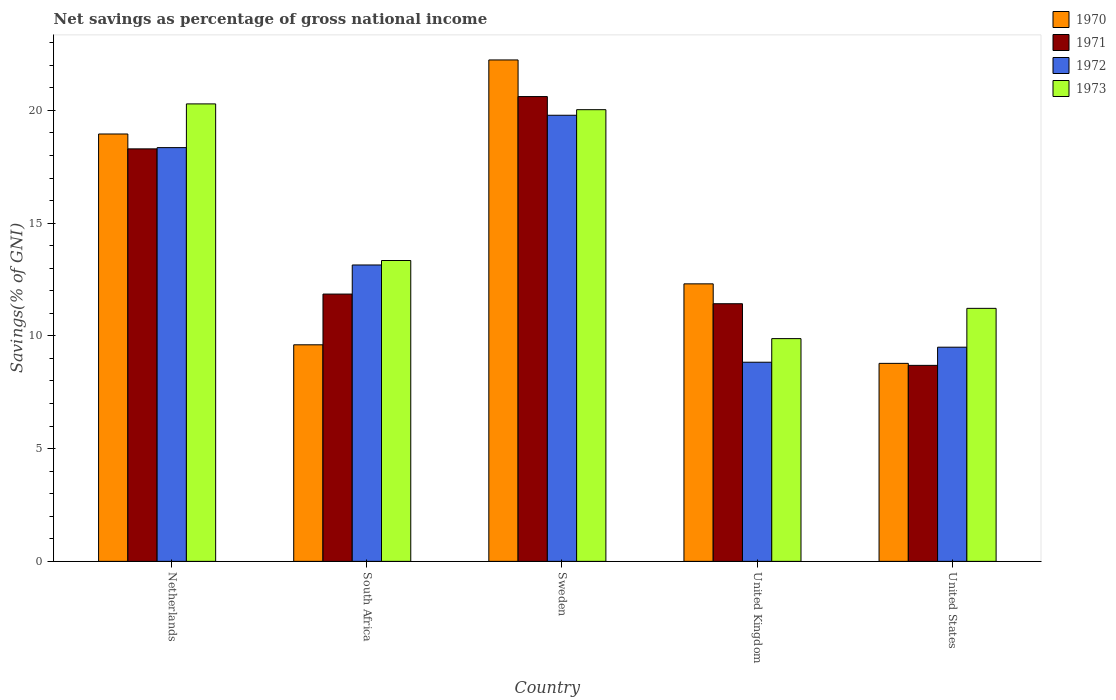Are the number of bars per tick equal to the number of legend labels?
Your response must be concise. Yes. Are the number of bars on each tick of the X-axis equal?
Make the answer very short. Yes. How many bars are there on the 4th tick from the left?
Keep it short and to the point. 4. In how many cases, is the number of bars for a given country not equal to the number of legend labels?
Your response must be concise. 0. What is the total savings in 1973 in South Africa?
Ensure brevity in your answer.  13.34. Across all countries, what is the maximum total savings in 1971?
Your answer should be compact. 20.61. Across all countries, what is the minimum total savings in 1973?
Give a very brief answer. 9.88. What is the total total savings in 1972 in the graph?
Your answer should be very brief. 69.6. What is the difference between the total savings in 1973 in Netherlands and that in United States?
Offer a terse response. 9.07. What is the difference between the total savings in 1972 in United Kingdom and the total savings in 1970 in Netherlands?
Give a very brief answer. -10.12. What is the average total savings in 1973 per country?
Offer a very short reply. 14.95. What is the difference between the total savings of/in 1972 and total savings of/in 1971 in United Kingdom?
Make the answer very short. -2.59. What is the ratio of the total savings in 1970 in South Africa to that in Sweden?
Make the answer very short. 0.43. What is the difference between the highest and the second highest total savings in 1973?
Your answer should be very brief. -6.95. What is the difference between the highest and the lowest total savings in 1972?
Make the answer very short. 10.95. In how many countries, is the total savings in 1970 greater than the average total savings in 1970 taken over all countries?
Provide a short and direct response. 2. Is the sum of the total savings in 1973 in Netherlands and United States greater than the maximum total savings in 1972 across all countries?
Keep it short and to the point. Yes. Is it the case that in every country, the sum of the total savings in 1972 and total savings in 1971 is greater than the sum of total savings in 1973 and total savings in 1970?
Offer a terse response. No. What does the 4th bar from the left in South Africa represents?
Make the answer very short. 1973. How many bars are there?
Give a very brief answer. 20. How many countries are there in the graph?
Ensure brevity in your answer.  5. What is the difference between two consecutive major ticks on the Y-axis?
Offer a terse response. 5. Are the values on the major ticks of Y-axis written in scientific E-notation?
Ensure brevity in your answer.  No. Where does the legend appear in the graph?
Make the answer very short. Top right. How many legend labels are there?
Offer a terse response. 4. How are the legend labels stacked?
Keep it short and to the point. Vertical. What is the title of the graph?
Make the answer very short. Net savings as percentage of gross national income. What is the label or title of the X-axis?
Provide a succinct answer. Country. What is the label or title of the Y-axis?
Offer a terse response. Savings(% of GNI). What is the Savings(% of GNI) in 1970 in Netherlands?
Keep it short and to the point. 18.95. What is the Savings(% of GNI) of 1971 in Netherlands?
Your answer should be very brief. 18.29. What is the Savings(% of GNI) of 1972 in Netherlands?
Give a very brief answer. 18.35. What is the Savings(% of GNI) in 1973 in Netherlands?
Your answer should be compact. 20.29. What is the Savings(% of GNI) of 1970 in South Africa?
Your answer should be very brief. 9.6. What is the Savings(% of GNI) in 1971 in South Africa?
Offer a terse response. 11.85. What is the Savings(% of GNI) of 1972 in South Africa?
Offer a very short reply. 13.14. What is the Savings(% of GNI) of 1973 in South Africa?
Ensure brevity in your answer.  13.34. What is the Savings(% of GNI) in 1970 in Sweden?
Keep it short and to the point. 22.24. What is the Savings(% of GNI) in 1971 in Sweden?
Offer a very short reply. 20.61. What is the Savings(% of GNI) of 1972 in Sweden?
Offer a very short reply. 19.78. What is the Savings(% of GNI) in 1973 in Sweden?
Your response must be concise. 20.03. What is the Savings(% of GNI) of 1970 in United Kingdom?
Your answer should be compact. 12.31. What is the Savings(% of GNI) of 1971 in United Kingdom?
Provide a short and direct response. 11.43. What is the Savings(% of GNI) of 1972 in United Kingdom?
Your answer should be compact. 8.83. What is the Savings(% of GNI) in 1973 in United Kingdom?
Your response must be concise. 9.88. What is the Savings(% of GNI) in 1970 in United States?
Give a very brief answer. 8.78. What is the Savings(% of GNI) of 1971 in United States?
Provide a short and direct response. 8.69. What is the Savings(% of GNI) in 1972 in United States?
Offer a very short reply. 9.5. What is the Savings(% of GNI) of 1973 in United States?
Your answer should be very brief. 11.22. Across all countries, what is the maximum Savings(% of GNI) of 1970?
Ensure brevity in your answer.  22.24. Across all countries, what is the maximum Savings(% of GNI) in 1971?
Ensure brevity in your answer.  20.61. Across all countries, what is the maximum Savings(% of GNI) of 1972?
Make the answer very short. 19.78. Across all countries, what is the maximum Savings(% of GNI) in 1973?
Your response must be concise. 20.29. Across all countries, what is the minimum Savings(% of GNI) in 1970?
Your response must be concise. 8.78. Across all countries, what is the minimum Savings(% of GNI) in 1971?
Keep it short and to the point. 8.69. Across all countries, what is the minimum Savings(% of GNI) of 1972?
Your answer should be compact. 8.83. Across all countries, what is the minimum Savings(% of GNI) of 1973?
Ensure brevity in your answer.  9.88. What is the total Savings(% of GNI) of 1970 in the graph?
Your response must be concise. 71.88. What is the total Savings(% of GNI) of 1971 in the graph?
Provide a short and direct response. 70.88. What is the total Savings(% of GNI) in 1972 in the graph?
Offer a terse response. 69.61. What is the total Savings(% of GNI) in 1973 in the graph?
Keep it short and to the point. 74.76. What is the difference between the Savings(% of GNI) of 1970 in Netherlands and that in South Africa?
Ensure brevity in your answer.  9.35. What is the difference between the Savings(% of GNI) in 1971 in Netherlands and that in South Africa?
Provide a succinct answer. 6.44. What is the difference between the Savings(% of GNI) in 1972 in Netherlands and that in South Africa?
Your answer should be compact. 5.21. What is the difference between the Savings(% of GNI) in 1973 in Netherlands and that in South Africa?
Provide a short and direct response. 6.95. What is the difference between the Savings(% of GNI) of 1970 in Netherlands and that in Sweden?
Give a very brief answer. -3.28. What is the difference between the Savings(% of GNI) of 1971 in Netherlands and that in Sweden?
Your answer should be very brief. -2.32. What is the difference between the Savings(% of GNI) of 1972 in Netherlands and that in Sweden?
Make the answer very short. -1.43. What is the difference between the Savings(% of GNI) of 1973 in Netherlands and that in Sweden?
Offer a terse response. 0.26. What is the difference between the Savings(% of GNI) in 1970 in Netherlands and that in United Kingdom?
Make the answer very short. 6.65. What is the difference between the Savings(% of GNI) of 1971 in Netherlands and that in United Kingdom?
Give a very brief answer. 6.87. What is the difference between the Savings(% of GNI) in 1972 in Netherlands and that in United Kingdom?
Provide a succinct answer. 9.52. What is the difference between the Savings(% of GNI) of 1973 in Netherlands and that in United Kingdom?
Provide a short and direct response. 10.41. What is the difference between the Savings(% of GNI) in 1970 in Netherlands and that in United States?
Your answer should be very brief. 10.17. What is the difference between the Savings(% of GNI) of 1971 in Netherlands and that in United States?
Your answer should be compact. 9.6. What is the difference between the Savings(% of GNI) in 1972 in Netherlands and that in United States?
Provide a succinct answer. 8.85. What is the difference between the Savings(% of GNI) in 1973 in Netherlands and that in United States?
Make the answer very short. 9.07. What is the difference between the Savings(% of GNI) in 1970 in South Africa and that in Sweden?
Keep it short and to the point. -12.63. What is the difference between the Savings(% of GNI) of 1971 in South Africa and that in Sweden?
Make the answer very short. -8.76. What is the difference between the Savings(% of GNI) of 1972 in South Africa and that in Sweden?
Offer a terse response. -6.64. What is the difference between the Savings(% of GNI) of 1973 in South Africa and that in Sweden?
Your answer should be compact. -6.69. What is the difference between the Savings(% of GNI) of 1970 in South Africa and that in United Kingdom?
Provide a succinct answer. -2.7. What is the difference between the Savings(% of GNI) in 1971 in South Africa and that in United Kingdom?
Provide a short and direct response. 0.43. What is the difference between the Savings(% of GNI) in 1972 in South Africa and that in United Kingdom?
Provide a short and direct response. 4.31. What is the difference between the Savings(% of GNI) of 1973 in South Africa and that in United Kingdom?
Keep it short and to the point. 3.46. What is the difference between the Savings(% of GNI) in 1970 in South Africa and that in United States?
Your answer should be compact. 0.82. What is the difference between the Savings(% of GNI) in 1971 in South Africa and that in United States?
Your response must be concise. 3.16. What is the difference between the Savings(% of GNI) in 1972 in South Africa and that in United States?
Offer a very short reply. 3.65. What is the difference between the Savings(% of GNI) in 1973 in South Africa and that in United States?
Your answer should be very brief. 2.12. What is the difference between the Savings(% of GNI) of 1970 in Sweden and that in United Kingdom?
Your response must be concise. 9.93. What is the difference between the Savings(% of GNI) in 1971 in Sweden and that in United Kingdom?
Give a very brief answer. 9.19. What is the difference between the Savings(% of GNI) in 1972 in Sweden and that in United Kingdom?
Provide a short and direct response. 10.95. What is the difference between the Savings(% of GNI) in 1973 in Sweden and that in United Kingdom?
Provide a short and direct response. 10.15. What is the difference between the Savings(% of GNI) in 1970 in Sweden and that in United States?
Provide a short and direct response. 13.46. What is the difference between the Savings(% of GNI) in 1971 in Sweden and that in United States?
Make the answer very short. 11.92. What is the difference between the Savings(% of GNI) in 1972 in Sweden and that in United States?
Your answer should be compact. 10.29. What is the difference between the Savings(% of GNI) in 1973 in Sweden and that in United States?
Make the answer very short. 8.81. What is the difference between the Savings(% of GNI) in 1970 in United Kingdom and that in United States?
Your answer should be very brief. 3.53. What is the difference between the Savings(% of GNI) of 1971 in United Kingdom and that in United States?
Offer a terse response. 2.73. What is the difference between the Savings(% of GNI) of 1972 in United Kingdom and that in United States?
Your answer should be very brief. -0.67. What is the difference between the Savings(% of GNI) of 1973 in United Kingdom and that in United States?
Ensure brevity in your answer.  -1.34. What is the difference between the Savings(% of GNI) of 1970 in Netherlands and the Savings(% of GNI) of 1971 in South Africa?
Offer a very short reply. 7.1. What is the difference between the Savings(% of GNI) of 1970 in Netherlands and the Savings(% of GNI) of 1972 in South Africa?
Give a very brief answer. 5.81. What is the difference between the Savings(% of GNI) of 1970 in Netherlands and the Savings(% of GNI) of 1973 in South Africa?
Ensure brevity in your answer.  5.61. What is the difference between the Savings(% of GNI) in 1971 in Netherlands and the Savings(% of GNI) in 1972 in South Africa?
Your answer should be very brief. 5.15. What is the difference between the Savings(% of GNI) in 1971 in Netherlands and the Savings(% of GNI) in 1973 in South Africa?
Ensure brevity in your answer.  4.95. What is the difference between the Savings(% of GNI) in 1972 in Netherlands and the Savings(% of GNI) in 1973 in South Africa?
Provide a short and direct response. 5.01. What is the difference between the Savings(% of GNI) in 1970 in Netherlands and the Savings(% of GNI) in 1971 in Sweden?
Make the answer very short. -1.66. What is the difference between the Savings(% of GNI) of 1970 in Netherlands and the Savings(% of GNI) of 1972 in Sweden?
Your answer should be very brief. -0.83. What is the difference between the Savings(% of GNI) of 1970 in Netherlands and the Savings(% of GNI) of 1973 in Sweden?
Your answer should be compact. -1.08. What is the difference between the Savings(% of GNI) of 1971 in Netherlands and the Savings(% of GNI) of 1972 in Sweden?
Offer a very short reply. -1.49. What is the difference between the Savings(% of GNI) of 1971 in Netherlands and the Savings(% of GNI) of 1973 in Sweden?
Your answer should be very brief. -1.74. What is the difference between the Savings(% of GNI) in 1972 in Netherlands and the Savings(% of GNI) in 1973 in Sweden?
Your answer should be very brief. -1.68. What is the difference between the Savings(% of GNI) in 1970 in Netherlands and the Savings(% of GNI) in 1971 in United Kingdom?
Give a very brief answer. 7.53. What is the difference between the Savings(% of GNI) of 1970 in Netherlands and the Savings(% of GNI) of 1972 in United Kingdom?
Give a very brief answer. 10.12. What is the difference between the Savings(% of GNI) in 1970 in Netherlands and the Savings(% of GNI) in 1973 in United Kingdom?
Your response must be concise. 9.07. What is the difference between the Savings(% of GNI) in 1971 in Netherlands and the Savings(% of GNI) in 1972 in United Kingdom?
Your answer should be very brief. 9.46. What is the difference between the Savings(% of GNI) in 1971 in Netherlands and the Savings(% of GNI) in 1973 in United Kingdom?
Your answer should be very brief. 8.42. What is the difference between the Savings(% of GNI) in 1972 in Netherlands and the Savings(% of GNI) in 1973 in United Kingdom?
Make the answer very short. 8.47. What is the difference between the Savings(% of GNI) in 1970 in Netherlands and the Savings(% of GNI) in 1971 in United States?
Your answer should be compact. 10.26. What is the difference between the Savings(% of GNI) of 1970 in Netherlands and the Savings(% of GNI) of 1972 in United States?
Give a very brief answer. 9.46. What is the difference between the Savings(% of GNI) in 1970 in Netherlands and the Savings(% of GNI) in 1973 in United States?
Your response must be concise. 7.73. What is the difference between the Savings(% of GNI) of 1971 in Netherlands and the Savings(% of GNI) of 1972 in United States?
Give a very brief answer. 8.8. What is the difference between the Savings(% of GNI) in 1971 in Netherlands and the Savings(% of GNI) in 1973 in United States?
Your response must be concise. 7.07. What is the difference between the Savings(% of GNI) of 1972 in Netherlands and the Savings(% of GNI) of 1973 in United States?
Offer a very short reply. 7.13. What is the difference between the Savings(% of GNI) in 1970 in South Africa and the Savings(% of GNI) in 1971 in Sweden?
Give a very brief answer. -11.01. What is the difference between the Savings(% of GNI) of 1970 in South Africa and the Savings(% of GNI) of 1972 in Sweden?
Your answer should be compact. -10.18. What is the difference between the Savings(% of GNI) of 1970 in South Africa and the Savings(% of GNI) of 1973 in Sweden?
Your answer should be very brief. -10.43. What is the difference between the Savings(% of GNI) of 1971 in South Africa and the Savings(% of GNI) of 1972 in Sweden?
Ensure brevity in your answer.  -7.93. What is the difference between the Savings(% of GNI) in 1971 in South Africa and the Savings(% of GNI) in 1973 in Sweden?
Provide a short and direct response. -8.18. What is the difference between the Savings(% of GNI) of 1972 in South Africa and the Savings(% of GNI) of 1973 in Sweden?
Ensure brevity in your answer.  -6.89. What is the difference between the Savings(% of GNI) in 1970 in South Africa and the Savings(% of GNI) in 1971 in United Kingdom?
Keep it short and to the point. -1.82. What is the difference between the Savings(% of GNI) in 1970 in South Africa and the Savings(% of GNI) in 1972 in United Kingdom?
Offer a very short reply. 0.77. What is the difference between the Savings(% of GNI) of 1970 in South Africa and the Savings(% of GNI) of 1973 in United Kingdom?
Provide a short and direct response. -0.27. What is the difference between the Savings(% of GNI) in 1971 in South Africa and the Savings(% of GNI) in 1972 in United Kingdom?
Offer a very short reply. 3.02. What is the difference between the Savings(% of GNI) in 1971 in South Africa and the Savings(% of GNI) in 1973 in United Kingdom?
Give a very brief answer. 1.98. What is the difference between the Savings(% of GNI) of 1972 in South Africa and the Savings(% of GNI) of 1973 in United Kingdom?
Give a very brief answer. 3.27. What is the difference between the Savings(% of GNI) of 1970 in South Africa and the Savings(% of GNI) of 1971 in United States?
Give a very brief answer. 0.91. What is the difference between the Savings(% of GNI) of 1970 in South Africa and the Savings(% of GNI) of 1972 in United States?
Keep it short and to the point. 0.11. What is the difference between the Savings(% of GNI) in 1970 in South Africa and the Savings(% of GNI) in 1973 in United States?
Your answer should be very brief. -1.62. What is the difference between the Savings(% of GNI) in 1971 in South Africa and the Savings(% of GNI) in 1972 in United States?
Ensure brevity in your answer.  2.36. What is the difference between the Savings(% of GNI) in 1971 in South Africa and the Savings(% of GNI) in 1973 in United States?
Offer a terse response. 0.63. What is the difference between the Savings(% of GNI) of 1972 in South Africa and the Savings(% of GNI) of 1973 in United States?
Your answer should be very brief. 1.92. What is the difference between the Savings(% of GNI) of 1970 in Sweden and the Savings(% of GNI) of 1971 in United Kingdom?
Give a very brief answer. 10.81. What is the difference between the Savings(% of GNI) in 1970 in Sweden and the Savings(% of GNI) in 1972 in United Kingdom?
Your response must be concise. 13.41. What is the difference between the Savings(% of GNI) in 1970 in Sweden and the Savings(% of GNI) in 1973 in United Kingdom?
Keep it short and to the point. 12.36. What is the difference between the Savings(% of GNI) in 1971 in Sweden and the Savings(% of GNI) in 1972 in United Kingdom?
Make the answer very short. 11.78. What is the difference between the Savings(% of GNI) of 1971 in Sweden and the Savings(% of GNI) of 1973 in United Kingdom?
Ensure brevity in your answer.  10.73. What is the difference between the Savings(% of GNI) of 1972 in Sweden and the Savings(% of GNI) of 1973 in United Kingdom?
Your answer should be very brief. 9.91. What is the difference between the Savings(% of GNI) of 1970 in Sweden and the Savings(% of GNI) of 1971 in United States?
Offer a very short reply. 13.54. What is the difference between the Savings(% of GNI) in 1970 in Sweden and the Savings(% of GNI) in 1972 in United States?
Make the answer very short. 12.74. What is the difference between the Savings(% of GNI) of 1970 in Sweden and the Savings(% of GNI) of 1973 in United States?
Provide a short and direct response. 11.02. What is the difference between the Savings(% of GNI) of 1971 in Sweden and the Savings(% of GNI) of 1972 in United States?
Ensure brevity in your answer.  11.12. What is the difference between the Savings(% of GNI) in 1971 in Sweden and the Savings(% of GNI) in 1973 in United States?
Offer a terse response. 9.39. What is the difference between the Savings(% of GNI) of 1972 in Sweden and the Savings(% of GNI) of 1973 in United States?
Provide a short and direct response. 8.56. What is the difference between the Savings(% of GNI) in 1970 in United Kingdom and the Savings(% of GNI) in 1971 in United States?
Offer a very short reply. 3.62. What is the difference between the Savings(% of GNI) of 1970 in United Kingdom and the Savings(% of GNI) of 1972 in United States?
Offer a terse response. 2.81. What is the difference between the Savings(% of GNI) in 1970 in United Kingdom and the Savings(% of GNI) in 1973 in United States?
Provide a succinct answer. 1.09. What is the difference between the Savings(% of GNI) in 1971 in United Kingdom and the Savings(% of GNI) in 1972 in United States?
Your answer should be very brief. 1.93. What is the difference between the Savings(% of GNI) of 1971 in United Kingdom and the Savings(% of GNI) of 1973 in United States?
Your answer should be compact. 0.2. What is the difference between the Savings(% of GNI) in 1972 in United Kingdom and the Savings(% of GNI) in 1973 in United States?
Your answer should be compact. -2.39. What is the average Savings(% of GNI) in 1970 per country?
Ensure brevity in your answer.  14.38. What is the average Savings(% of GNI) of 1971 per country?
Provide a short and direct response. 14.18. What is the average Savings(% of GNI) in 1972 per country?
Your response must be concise. 13.92. What is the average Savings(% of GNI) of 1973 per country?
Your answer should be compact. 14.95. What is the difference between the Savings(% of GNI) of 1970 and Savings(% of GNI) of 1971 in Netherlands?
Offer a terse response. 0.66. What is the difference between the Savings(% of GNI) of 1970 and Savings(% of GNI) of 1972 in Netherlands?
Provide a succinct answer. 0.6. What is the difference between the Savings(% of GNI) of 1970 and Savings(% of GNI) of 1973 in Netherlands?
Ensure brevity in your answer.  -1.33. What is the difference between the Savings(% of GNI) in 1971 and Savings(% of GNI) in 1972 in Netherlands?
Ensure brevity in your answer.  -0.06. What is the difference between the Savings(% of GNI) in 1971 and Savings(% of GNI) in 1973 in Netherlands?
Offer a terse response. -1.99. What is the difference between the Savings(% of GNI) of 1972 and Savings(% of GNI) of 1973 in Netherlands?
Your answer should be compact. -1.94. What is the difference between the Savings(% of GNI) of 1970 and Savings(% of GNI) of 1971 in South Africa?
Your response must be concise. -2.25. What is the difference between the Savings(% of GNI) in 1970 and Savings(% of GNI) in 1972 in South Africa?
Make the answer very short. -3.54. What is the difference between the Savings(% of GNI) in 1970 and Savings(% of GNI) in 1973 in South Africa?
Ensure brevity in your answer.  -3.74. What is the difference between the Savings(% of GNI) in 1971 and Savings(% of GNI) in 1972 in South Africa?
Provide a short and direct response. -1.29. What is the difference between the Savings(% of GNI) of 1971 and Savings(% of GNI) of 1973 in South Africa?
Ensure brevity in your answer.  -1.49. What is the difference between the Savings(% of GNI) of 1972 and Savings(% of GNI) of 1973 in South Africa?
Provide a short and direct response. -0.2. What is the difference between the Savings(% of GNI) of 1970 and Savings(% of GNI) of 1971 in Sweden?
Your answer should be compact. 1.62. What is the difference between the Savings(% of GNI) in 1970 and Savings(% of GNI) in 1972 in Sweden?
Offer a terse response. 2.45. What is the difference between the Savings(% of GNI) in 1970 and Savings(% of GNI) in 1973 in Sweden?
Your answer should be very brief. 2.21. What is the difference between the Savings(% of GNI) of 1971 and Savings(% of GNI) of 1972 in Sweden?
Offer a very short reply. 0.83. What is the difference between the Savings(% of GNI) in 1971 and Savings(% of GNI) in 1973 in Sweden?
Provide a short and direct response. 0.58. What is the difference between the Savings(% of GNI) of 1972 and Savings(% of GNI) of 1973 in Sweden?
Give a very brief answer. -0.25. What is the difference between the Savings(% of GNI) in 1970 and Savings(% of GNI) in 1971 in United Kingdom?
Keep it short and to the point. 0.88. What is the difference between the Savings(% of GNI) of 1970 and Savings(% of GNI) of 1972 in United Kingdom?
Your answer should be compact. 3.48. What is the difference between the Savings(% of GNI) of 1970 and Savings(% of GNI) of 1973 in United Kingdom?
Your answer should be compact. 2.43. What is the difference between the Savings(% of GNI) of 1971 and Savings(% of GNI) of 1972 in United Kingdom?
Give a very brief answer. 2.59. What is the difference between the Savings(% of GNI) of 1971 and Savings(% of GNI) of 1973 in United Kingdom?
Make the answer very short. 1.55. What is the difference between the Savings(% of GNI) in 1972 and Savings(% of GNI) in 1973 in United Kingdom?
Your answer should be compact. -1.05. What is the difference between the Savings(% of GNI) of 1970 and Savings(% of GNI) of 1971 in United States?
Offer a very short reply. 0.09. What is the difference between the Savings(% of GNI) in 1970 and Savings(% of GNI) in 1972 in United States?
Keep it short and to the point. -0.72. What is the difference between the Savings(% of GNI) in 1970 and Savings(% of GNI) in 1973 in United States?
Your answer should be compact. -2.44. What is the difference between the Savings(% of GNI) of 1971 and Savings(% of GNI) of 1972 in United States?
Your response must be concise. -0.81. What is the difference between the Savings(% of GNI) of 1971 and Savings(% of GNI) of 1973 in United States?
Offer a terse response. -2.53. What is the difference between the Savings(% of GNI) in 1972 and Savings(% of GNI) in 1973 in United States?
Offer a very short reply. -1.72. What is the ratio of the Savings(% of GNI) of 1970 in Netherlands to that in South Africa?
Offer a very short reply. 1.97. What is the ratio of the Savings(% of GNI) in 1971 in Netherlands to that in South Africa?
Make the answer very short. 1.54. What is the ratio of the Savings(% of GNI) in 1972 in Netherlands to that in South Africa?
Your answer should be compact. 1.4. What is the ratio of the Savings(% of GNI) in 1973 in Netherlands to that in South Africa?
Keep it short and to the point. 1.52. What is the ratio of the Savings(% of GNI) of 1970 in Netherlands to that in Sweden?
Provide a short and direct response. 0.85. What is the ratio of the Savings(% of GNI) in 1971 in Netherlands to that in Sweden?
Your response must be concise. 0.89. What is the ratio of the Savings(% of GNI) in 1972 in Netherlands to that in Sweden?
Your response must be concise. 0.93. What is the ratio of the Savings(% of GNI) of 1973 in Netherlands to that in Sweden?
Your answer should be compact. 1.01. What is the ratio of the Savings(% of GNI) of 1970 in Netherlands to that in United Kingdom?
Provide a succinct answer. 1.54. What is the ratio of the Savings(% of GNI) of 1971 in Netherlands to that in United Kingdom?
Provide a short and direct response. 1.6. What is the ratio of the Savings(% of GNI) in 1972 in Netherlands to that in United Kingdom?
Provide a short and direct response. 2.08. What is the ratio of the Savings(% of GNI) in 1973 in Netherlands to that in United Kingdom?
Your answer should be very brief. 2.05. What is the ratio of the Savings(% of GNI) of 1970 in Netherlands to that in United States?
Provide a succinct answer. 2.16. What is the ratio of the Savings(% of GNI) in 1971 in Netherlands to that in United States?
Make the answer very short. 2.1. What is the ratio of the Savings(% of GNI) of 1972 in Netherlands to that in United States?
Your response must be concise. 1.93. What is the ratio of the Savings(% of GNI) in 1973 in Netherlands to that in United States?
Keep it short and to the point. 1.81. What is the ratio of the Savings(% of GNI) in 1970 in South Africa to that in Sweden?
Your response must be concise. 0.43. What is the ratio of the Savings(% of GNI) in 1971 in South Africa to that in Sweden?
Give a very brief answer. 0.58. What is the ratio of the Savings(% of GNI) of 1972 in South Africa to that in Sweden?
Provide a short and direct response. 0.66. What is the ratio of the Savings(% of GNI) of 1973 in South Africa to that in Sweden?
Ensure brevity in your answer.  0.67. What is the ratio of the Savings(% of GNI) of 1970 in South Africa to that in United Kingdom?
Keep it short and to the point. 0.78. What is the ratio of the Savings(% of GNI) in 1971 in South Africa to that in United Kingdom?
Provide a short and direct response. 1.04. What is the ratio of the Savings(% of GNI) in 1972 in South Africa to that in United Kingdom?
Provide a short and direct response. 1.49. What is the ratio of the Savings(% of GNI) in 1973 in South Africa to that in United Kingdom?
Keep it short and to the point. 1.35. What is the ratio of the Savings(% of GNI) of 1970 in South Africa to that in United States?
Provide a short and direct response. 1.09. What is the ratio of the Savings(% of GNI) in 1971 in South Africa to that in United States?
Offer a very short reply. 1.36. What is the ratio of the Savings(% of GNI) of 1972 in South Africa to that in United States?
Make the answer very short. 1.38. What is the ratio of the Savings(% of GNI) in 1973 in South Africa to that in United States?
Offer a very short reply. 1.19. What is the ratio of the Savings(% of GNI) of 1970 in Sweden to that in United Kingdom?
Provide a succinct answer. 1.81. What is the ratio of the Savings(% of GNI) in 1971 in Sweden to that in United Kingdom?
Keep it short and to the point. 1.8. What is the ratio of the Savings(% of GNI) of 1972 in Sweden to that in United Kingdom?
Keep it short and to the point. 2.24. What is the ratio of the Savings(% of GNI) in 1973 in Sweden to that in United Kingdom?
Your answer should be very brief. 2.03. What is the ratio of the Savings(% of GNI) of 1970 in Sweden to that in United States?
Your answer should be very brief. 2.53. What is the ratio of the Savings(% of GNI) in 1971 in Sweden to that in United States?
Your answer should be compact. 2.37. What is the ratio of the Savings(% of GNI) in 1972 in Sweden to that in United States?
Your response must be concise. 2.08. What is the ratio of the Savings(% of GNI) in 1973 in Sweden to that in United States?
Make the answer very short. 1.79. What is the ratio of the Savings(% of GNI) in 1970 in United Kingdom to that in United States?
Your answer should be very brief. 1.4. What is the ratio of the Savings(% of GNI) of 1971 in United Kingdom to that in United States?
Provide a succinct answer. 1.31. What is the ratio of the Savings(% of GNI) of 1972 in United Kingdom to that in United States?
Your answer should be compact. 0.93. What is the ratio of the Savings(% of GNI) of 1973 in United Kingdom to that in United States?
Offer a terse response. 0.88. What is the difference between the highest and the second highest Savings(% of GNI) in 1970?
Provide a succinct answer. 3.28. What is the difference between the highest and the second highest Savings(% of GNI) of 1971?
Give a very brief answer. 2.32. What is the difference between the highest and the second highest Savings(% of GNI) of 1972?
Keep it short and to the point. 1.43. What is the difference between the highest and the second highest Savings(% of GNI) in 1973?
Give a very brief answer. 0.26. What is the difference between the highest and the lowest Savings(% of GNI) of 1970?
Your response must be concise. 13.46. What is the difference between the highest and the lowest Savings(% of GNI) of 1971?
Offer a terse response. 11.92. What is the difference between the highest and the lowest Savings(% of GNI) of 1972?
Offer a very short reply. 10.95. What is the difference between the highest and the lowest Savings(% of GNI) of 1973?
Give a very brief answer. 10.41. 